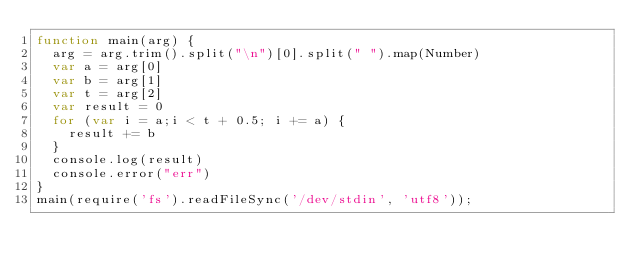Convert code to text. <code><loc_0><loc_0><loc_500><loc_500><_JavaScript_>function main(arg) {
	arg = arg.trim().split("\n")[0].split(" ").map(Number)
	var a = arg[0]
	var b = arg[1]
	var t = arg[2]
	var result = 0
	for (var i = a;i < t + 0.5; i += a) {
		result += b
	}
	console.log(result)
  console.error("err")
}
main(require('fs').readFileSync('/dev/stdin', 'utf8'));
</code> 